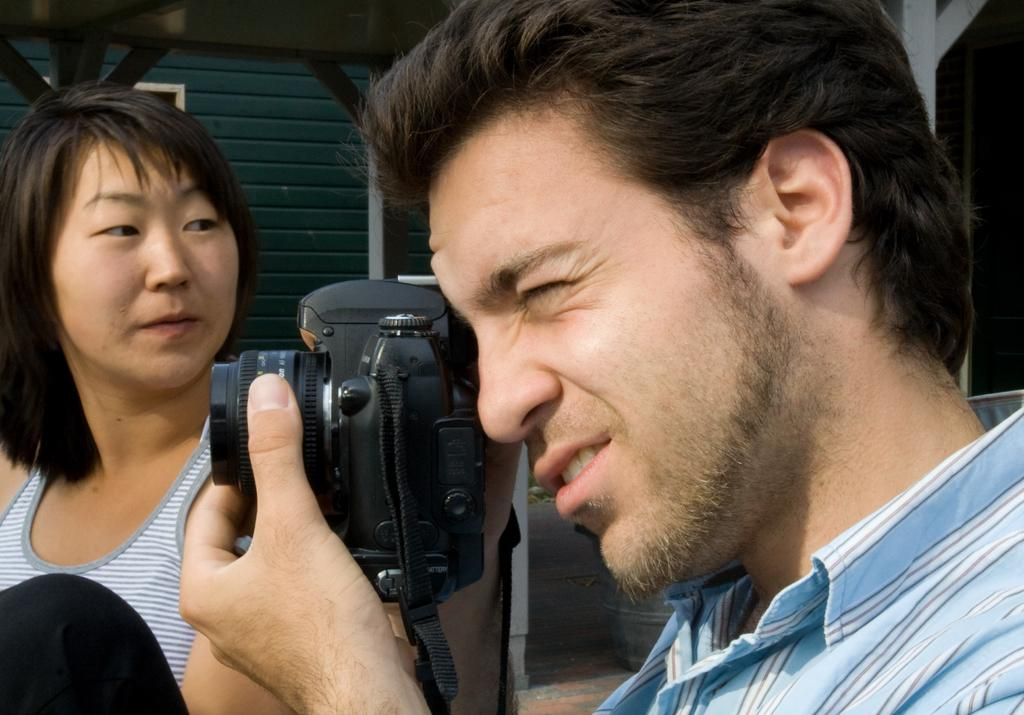How many people are in the image? There are two people in the image. What is one of the people doing in the image? One person is holding a camera. What type of punishment is being administered to the person holding the camera in the image? There is no punishment being administered in the image; the person is simply holding a camera. 